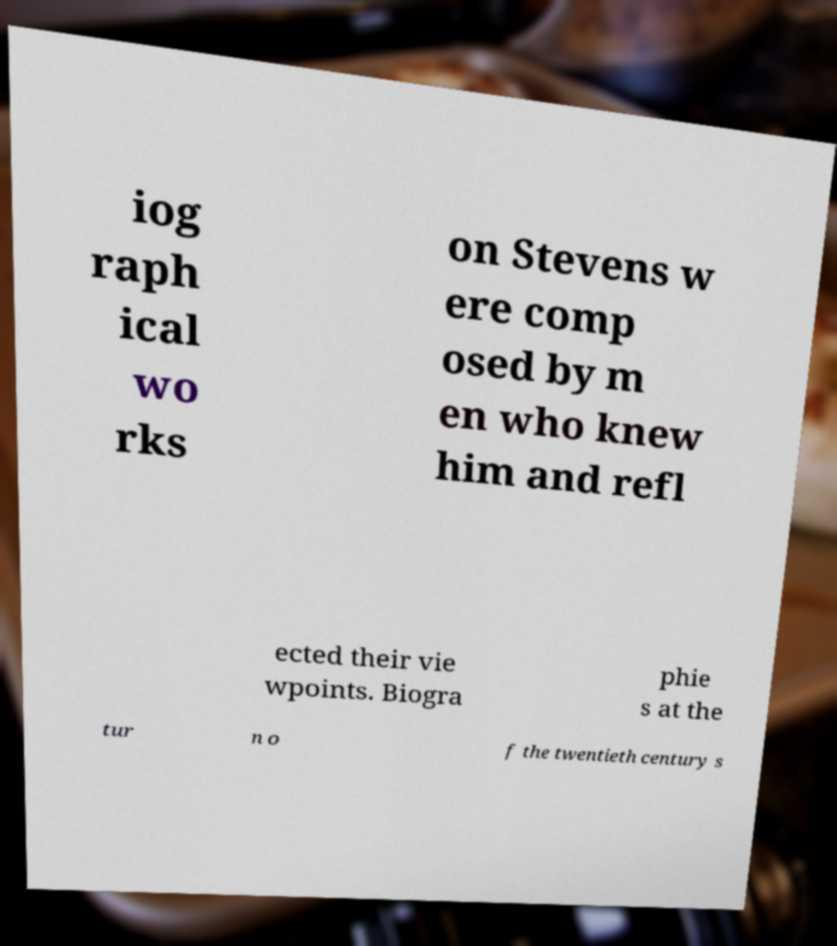Can you read and provide the text displayed in the image?This photo seems to have some interesting text. Can you extract and type it out for me? iog raph ical wo rks on Stevens w ere comp osed by m en who knew him and refl ected their vie wpoints. Biogra phie s at the tur n o f the twentieth century s 